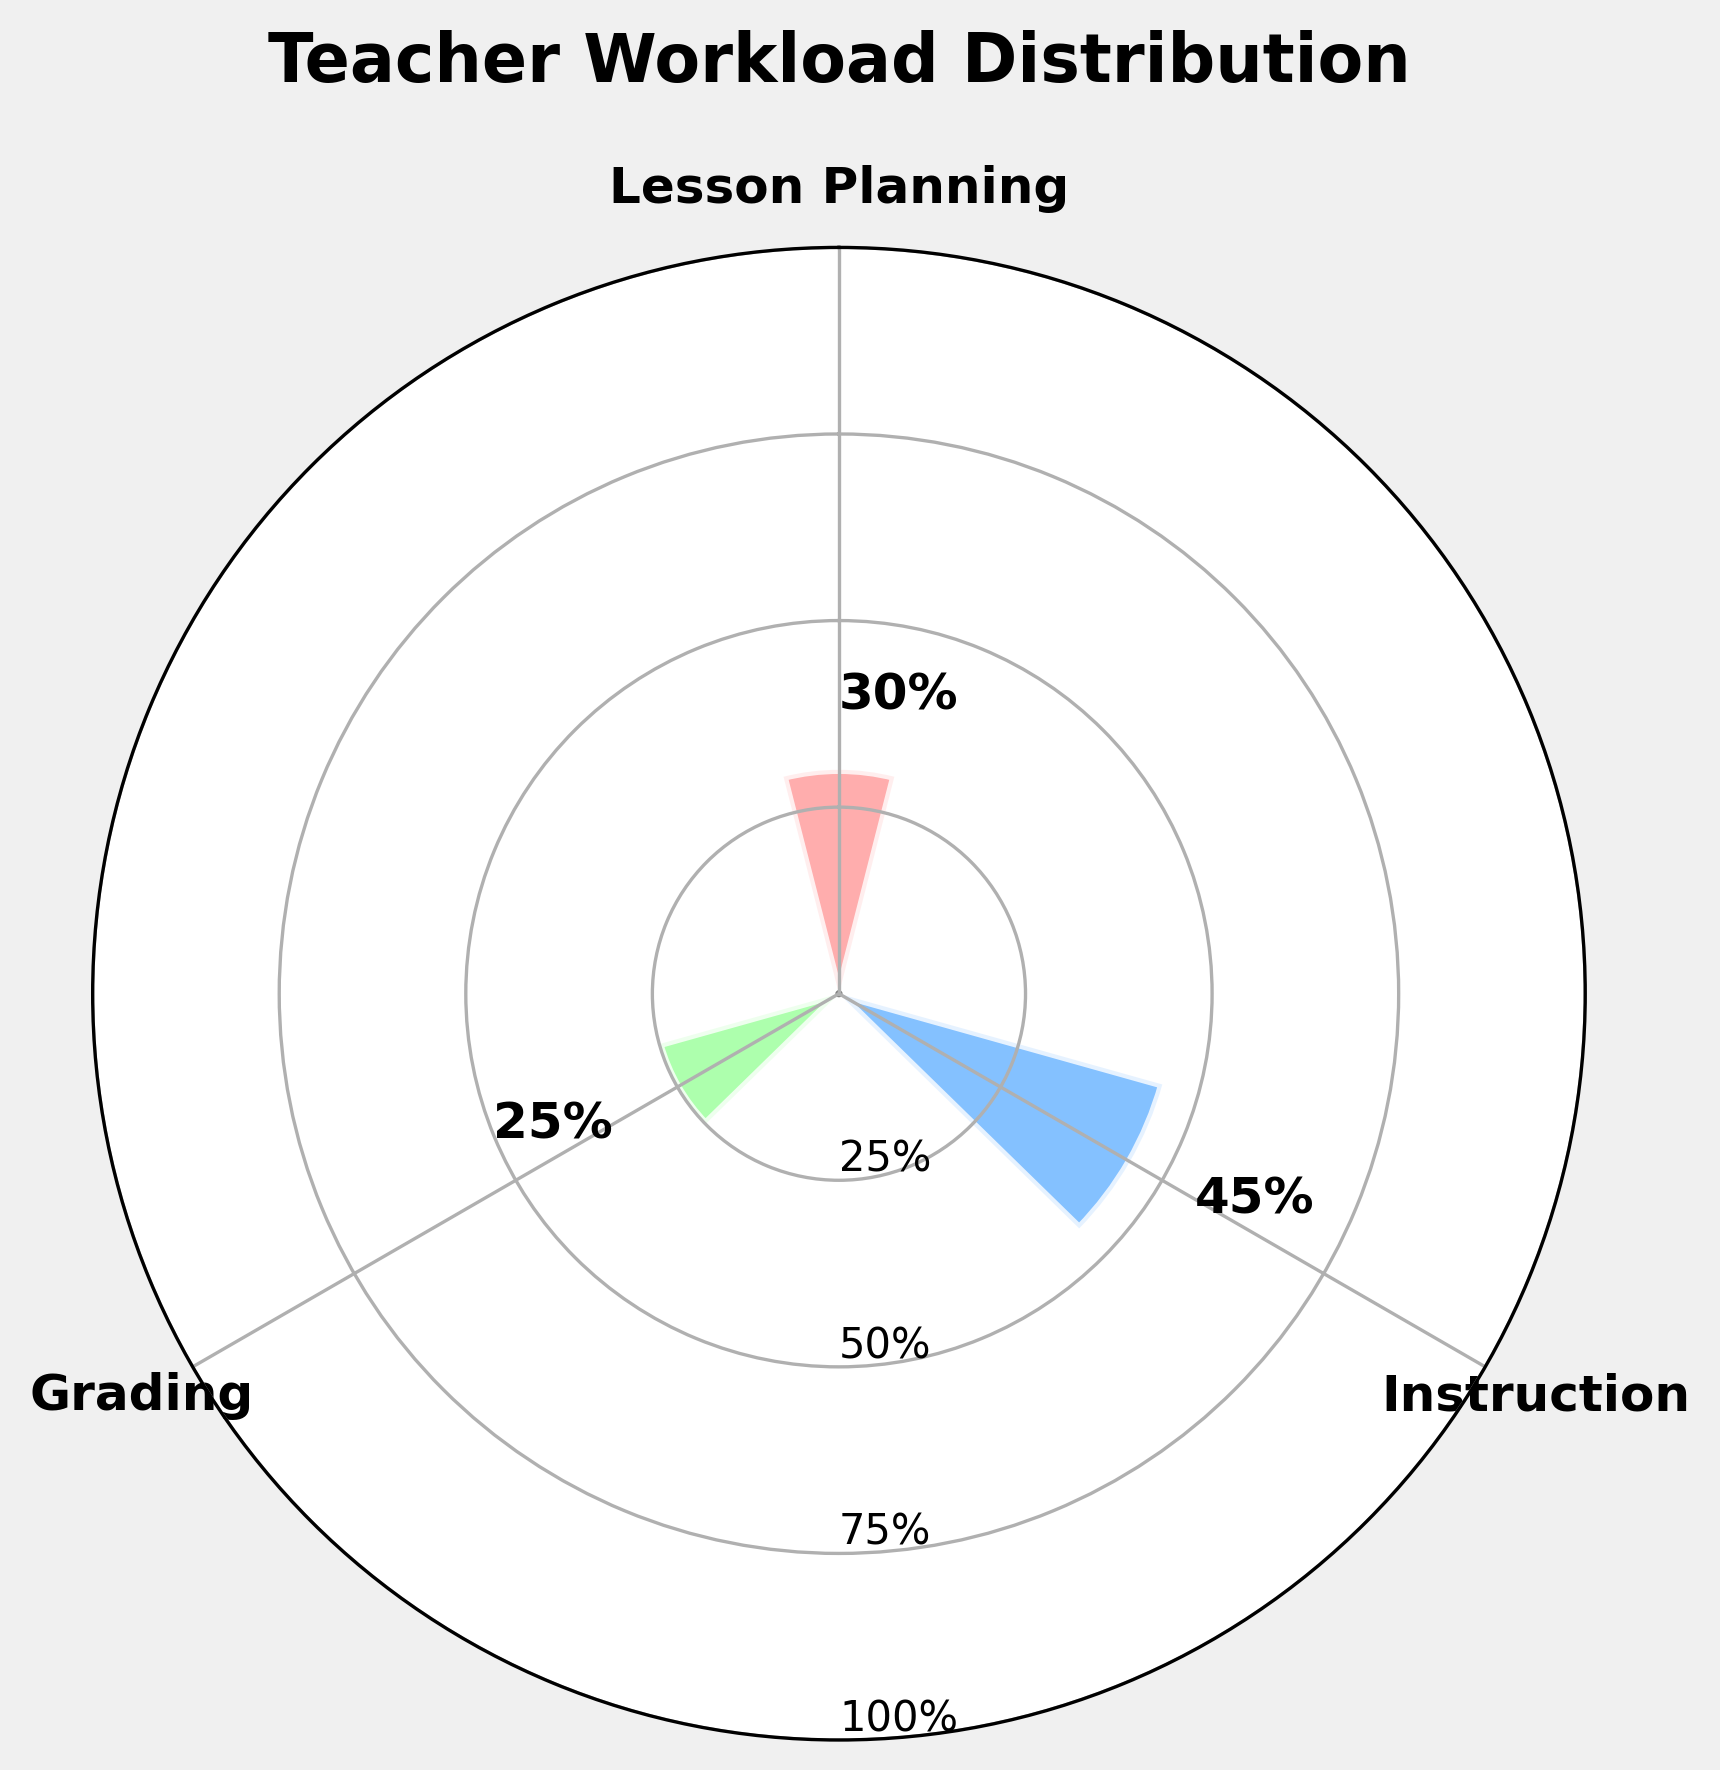What is the title of the chart? The title is usually located at the top center of the chart and is clearly labeled.
Answer: Teacher Workload Distribution How many percentage points is spent on Lesson Planning? Check the label next to the bar for Lesson Planning.
Answer: 30% Which category has the highest percentage? Compare the percentages of Lesson Planning, Instruction, and Grading. The highest percentage will be the one with the tallest bar and the largest value next to it.
Answer: Instruction How does the percentage of Grading compare to Instruction? Identify the percentages for both Grading and Instruction. Instruction has 45%, while Grading has 25%. Since 25% < 45%, Grading is lower.
Answer: Grading is lower What is the total percentage of Lesson Planning and Grading combined? Add the percentage for Lesson Planning to the percentage for Grading: 30% + 25%.
Answer: 55% What color represents the Instruction category? Locate which bar represents Instruction and note its color. Instruction is shown in blue.
Answer: Blue Which category requires less workload than Lesson Planning but more than Grading? Identify where the percentages fall between Lesson Planning (30%) and Grading (25%). Instruction (45%) is greater than 30%, so it's not correct. None fits the description.
Answer: None What is the average percentage spent on Lesson Planning, Instruction, and Grading? Add all percentages: 30% + 45% + 25% = 100%, then divide by the number of categories (3). So, 100% /3 = 33.33%.
Answer: 33.33% What is the angle offset for the Instruction category in the chart? Gauging from the start of the lesson planning angle (usually positioned straight above), Instruction (coming right afterward) would be 1/3rd along the circle: 360° * 1/3 = 120°.
Answer: 120° If the percentages were to be evenly distributed, what would each category's percentage be? For an even distribution among 3 categories, divide 100% by 3. So, 100% /3 = 33.33%.
Answer: 33.33% 